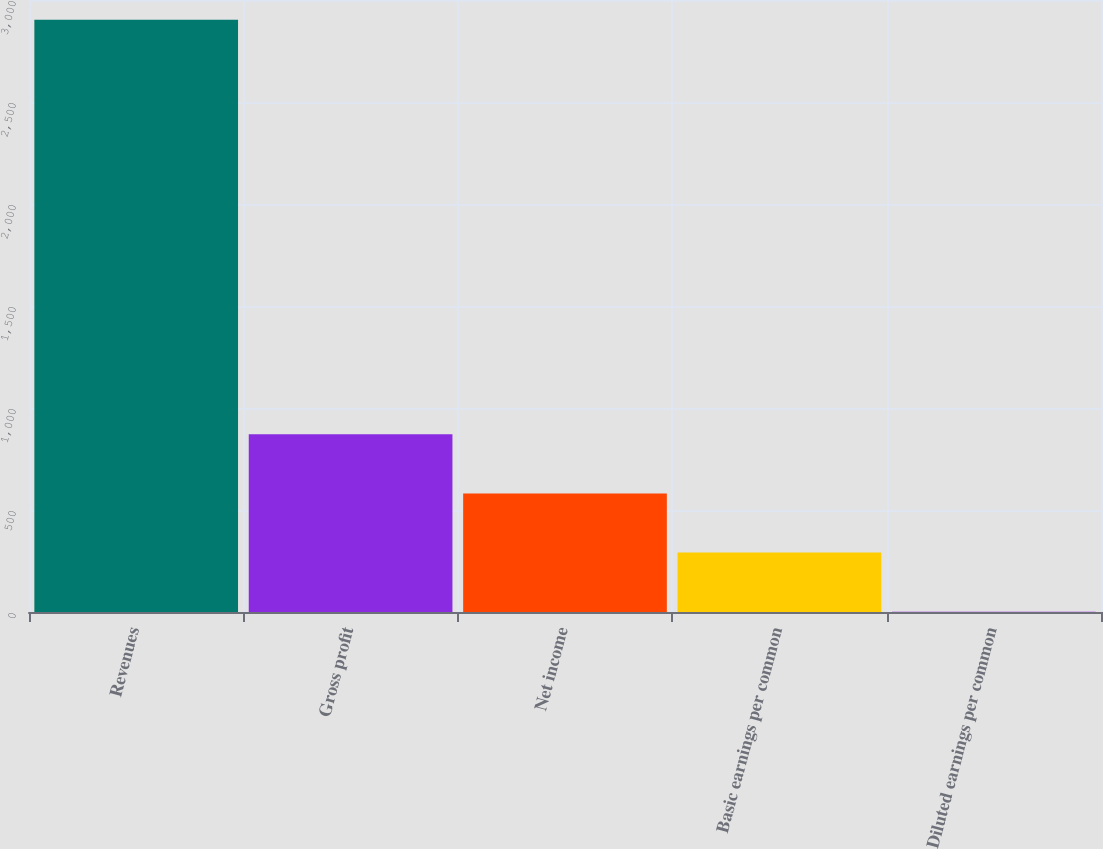Convert chart to OTSL. <chart><loc_0><loc_0><loc_500><loc_500><bar_chart><fcel>Revenues<fcel>Gross profit<fcel>Net income<fcel>Basic earnings per common<fcel>Diluted earnings per common<nl><fcel>2903.1<fcel>871.61<fcel>581.4<fcel>291.19<fcel>0.98<nl></chart> 